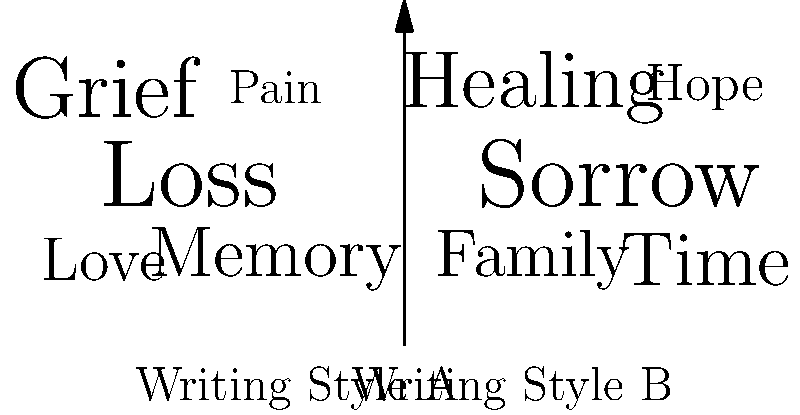Based on the word clouds representing two different writing styles in memoirs about bereavement, which style appears to focus more on the process of recovery and future-oriented themes? To answer this question, we need to analyze the content and prominence of words in each word cloud:

1. Writing Style A (left cloud):
   - Dominant words: "Loss" and "Grief"
   - Other words: "Memory", "Love", "Pain"
   - Overall theme: Focuses on the immediate experience of loss and emotional pain

2. Writing Style B (right cloud):
   - Dominant word: "Sorrow"
   - Other prominent words: "Healing", "Time", "Family", "Hope"
   - Overall theme: While acknowledging sorrow, it includes words related to the healing process and future outlook

3. Comparison:
   - Style A emphasizes the raw emotions of grief and loss
   - Style B includes words like "Healing" and "Hope", suggesting a focus on recovery
   - "Time" in Style B implies a forward-looking perspective
   - "Family" in Style B could indicate support systems or moving forward with loved ones

4. Conclusion:
   Writing Style B appears to focus more on the process of recovery and future-oriented themes, as evidenced by the inclusion and prominence of words like "Healing", "Time", and "Hope".
Answer: Writing Style B 